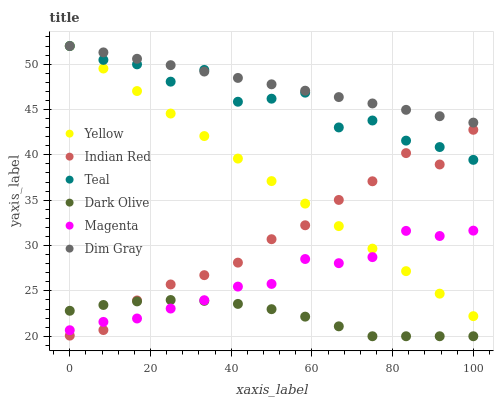Does Dark Olive have the minimum area under the curve?
Answer yes or no. Yes. Does Dim Gray have the maximum area under the curve?
Answer yes or no. Yes. Does Indian Red have the minimum area under the curve?
Answer yes or no. No. Does Indian Red have the maximum area under the curve?
Answer yes or no. No. Is Dim Gray the smoothest?
Answer yes or no. Yes. Is Teal the roughest?
Answer yes or no. Yes. Is Indian Red the smoothest?
Answer yes or no. No. Is Indian Red the roughest?
Answer yes or no. No. Does Dark Olive have the lowest value?
Answer yes or no. Yes. Does Indian Red have the lowest value?
Answer yes or no. No. Does Teal have the highest value?
Answer yes or no. Yes. Does Indian Red have the highest value?
Answer yes or no. No. Is Dark Olive less than Yellow?
Answer yes or no. Yes. Is Dim Gray greater than Magenta?
Answer yes or no. Yes. Does Yellow intersect Teal?
Answer yes or no. Yes. Is Yellow less than Teal?
Answer yes or no. No. Is Yellow greater than Teal?
Answer yes or no. No. Does Dark Olive intersect Yellow?
Answer yes or no. No. 